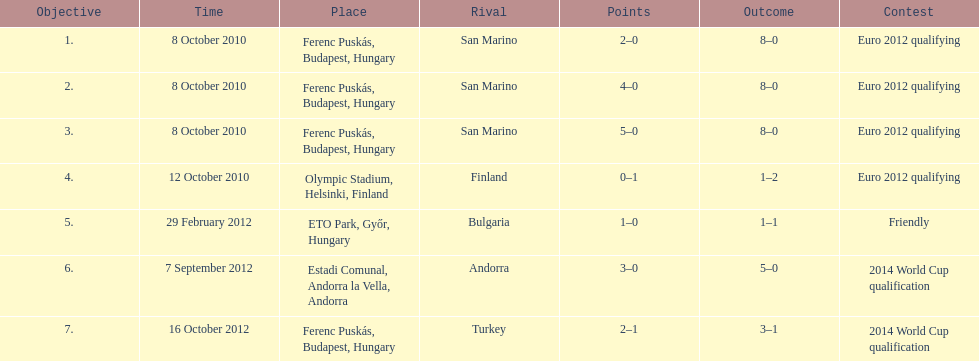How many games did he score but his team lost? 1. 